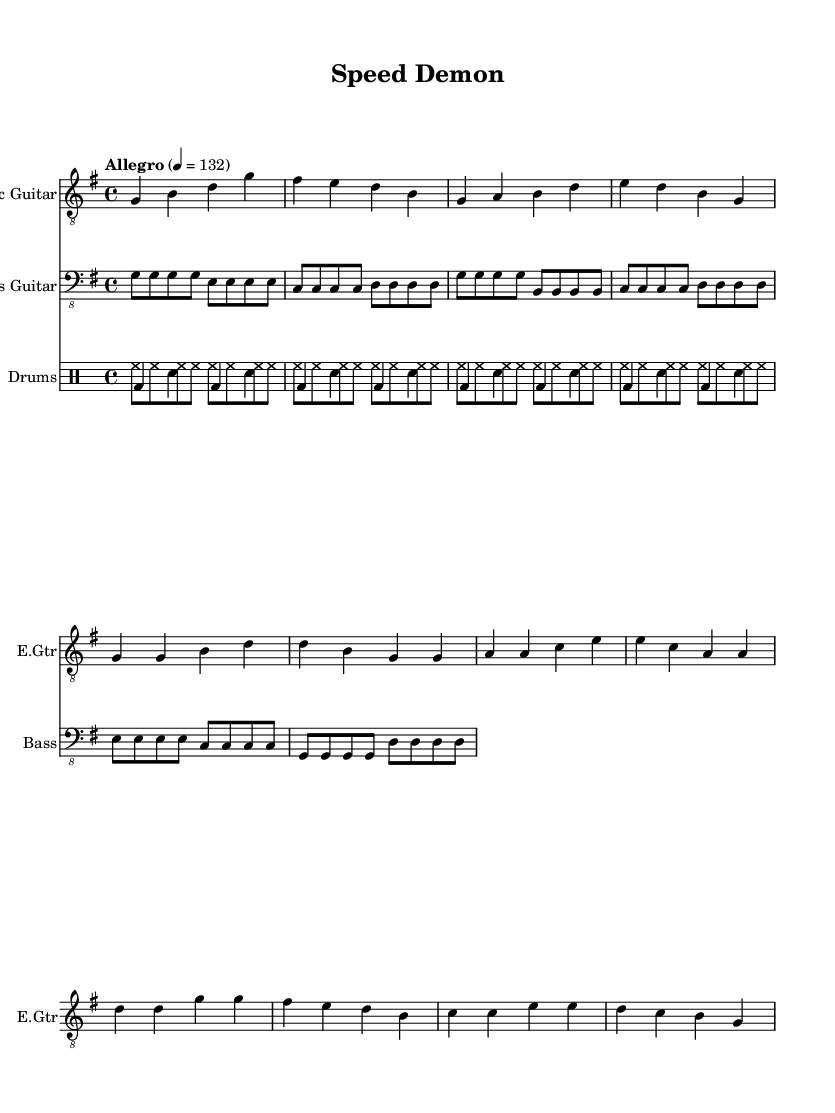What is the key signature of this music? The key signature is G major, which has one sharp (F#).
Answer: G major What is the time signature of this music? The time signature is four-four, indicating four beats per measure.
Answer: 4/4 What is the tempo marking of this piece? The tempo marking indicates "Allegro" with a BPM of 132.
Answer: Allegro, 132 How many measures are in the electric guitar part? The electric guitar part contains eight measures, as indicated by counting the bar lines.
Answer: Eight measures What is the primary instrument used in this piece? The primary instrument is the electric guitar, as it is featured prominently at the beginning of the score.
Answer: Electric guitar Which rhythmic pattern is consistently used in the drum part? The consistent pattern in the drum part involves alternating between the bass drum and snare, creating a driving rhythm.
Answer: Alternating bass and snare What is the overall mood or style intended for this soundtrack? The overall mood intended for this soundtrack is motivational and energetic, suitable for fitness and workout scenarios.
Answer: Motivational and energetic 